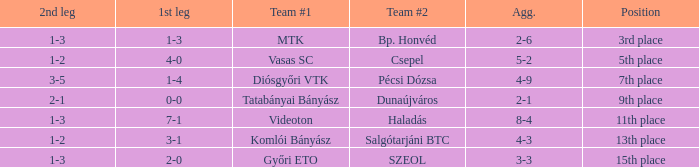What is the 1st leg of bp. honvéd team #2? 1-3. 